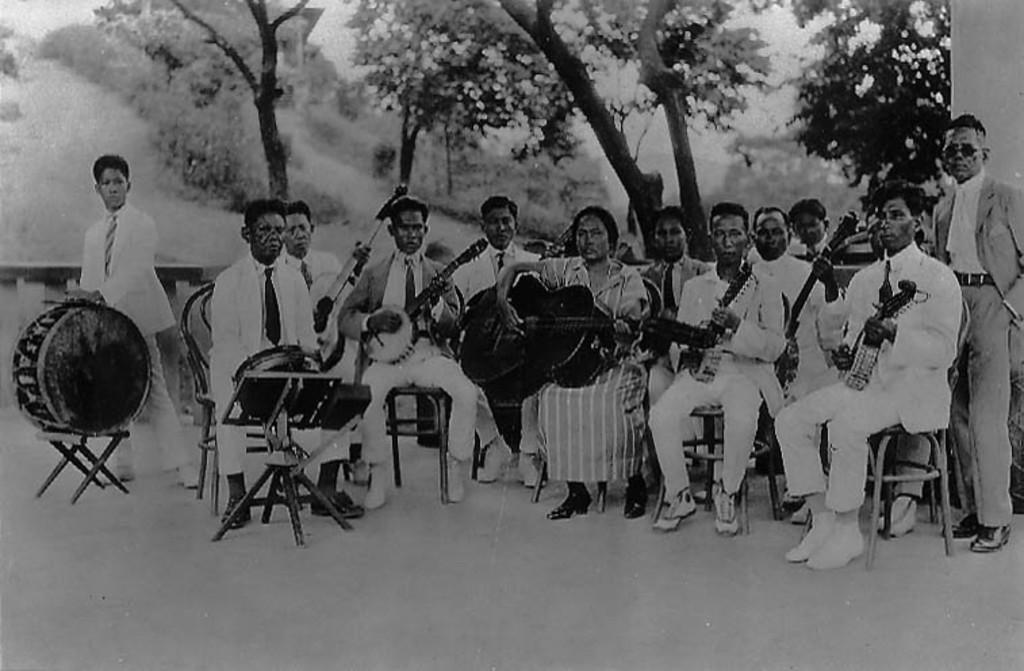Could you give a brief overview of what you see in this image? It is a black and white image, there are group of people playing musical instruments and behind them there are some trees. 